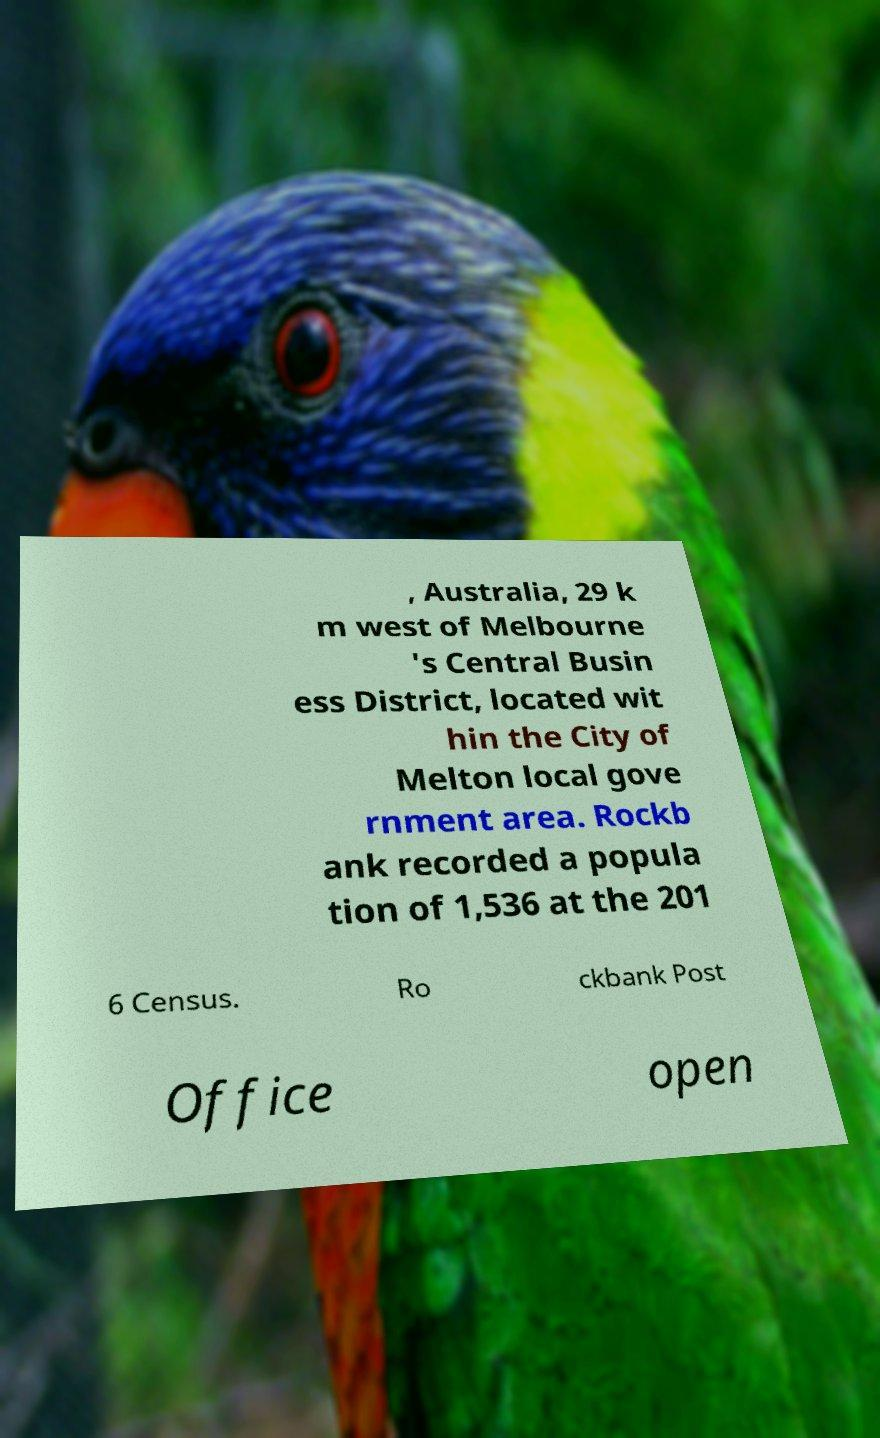I need the written content from this picture converted into text. Can you do that? , Australia, 29 k m west of Melbourne 's Central Busin ess District, located wit hin the City of Melton local gove rnment area. Rockb ank recorded a popula tion of 1,536 at the 201 6 Census. Ro ckbank Post Office open 